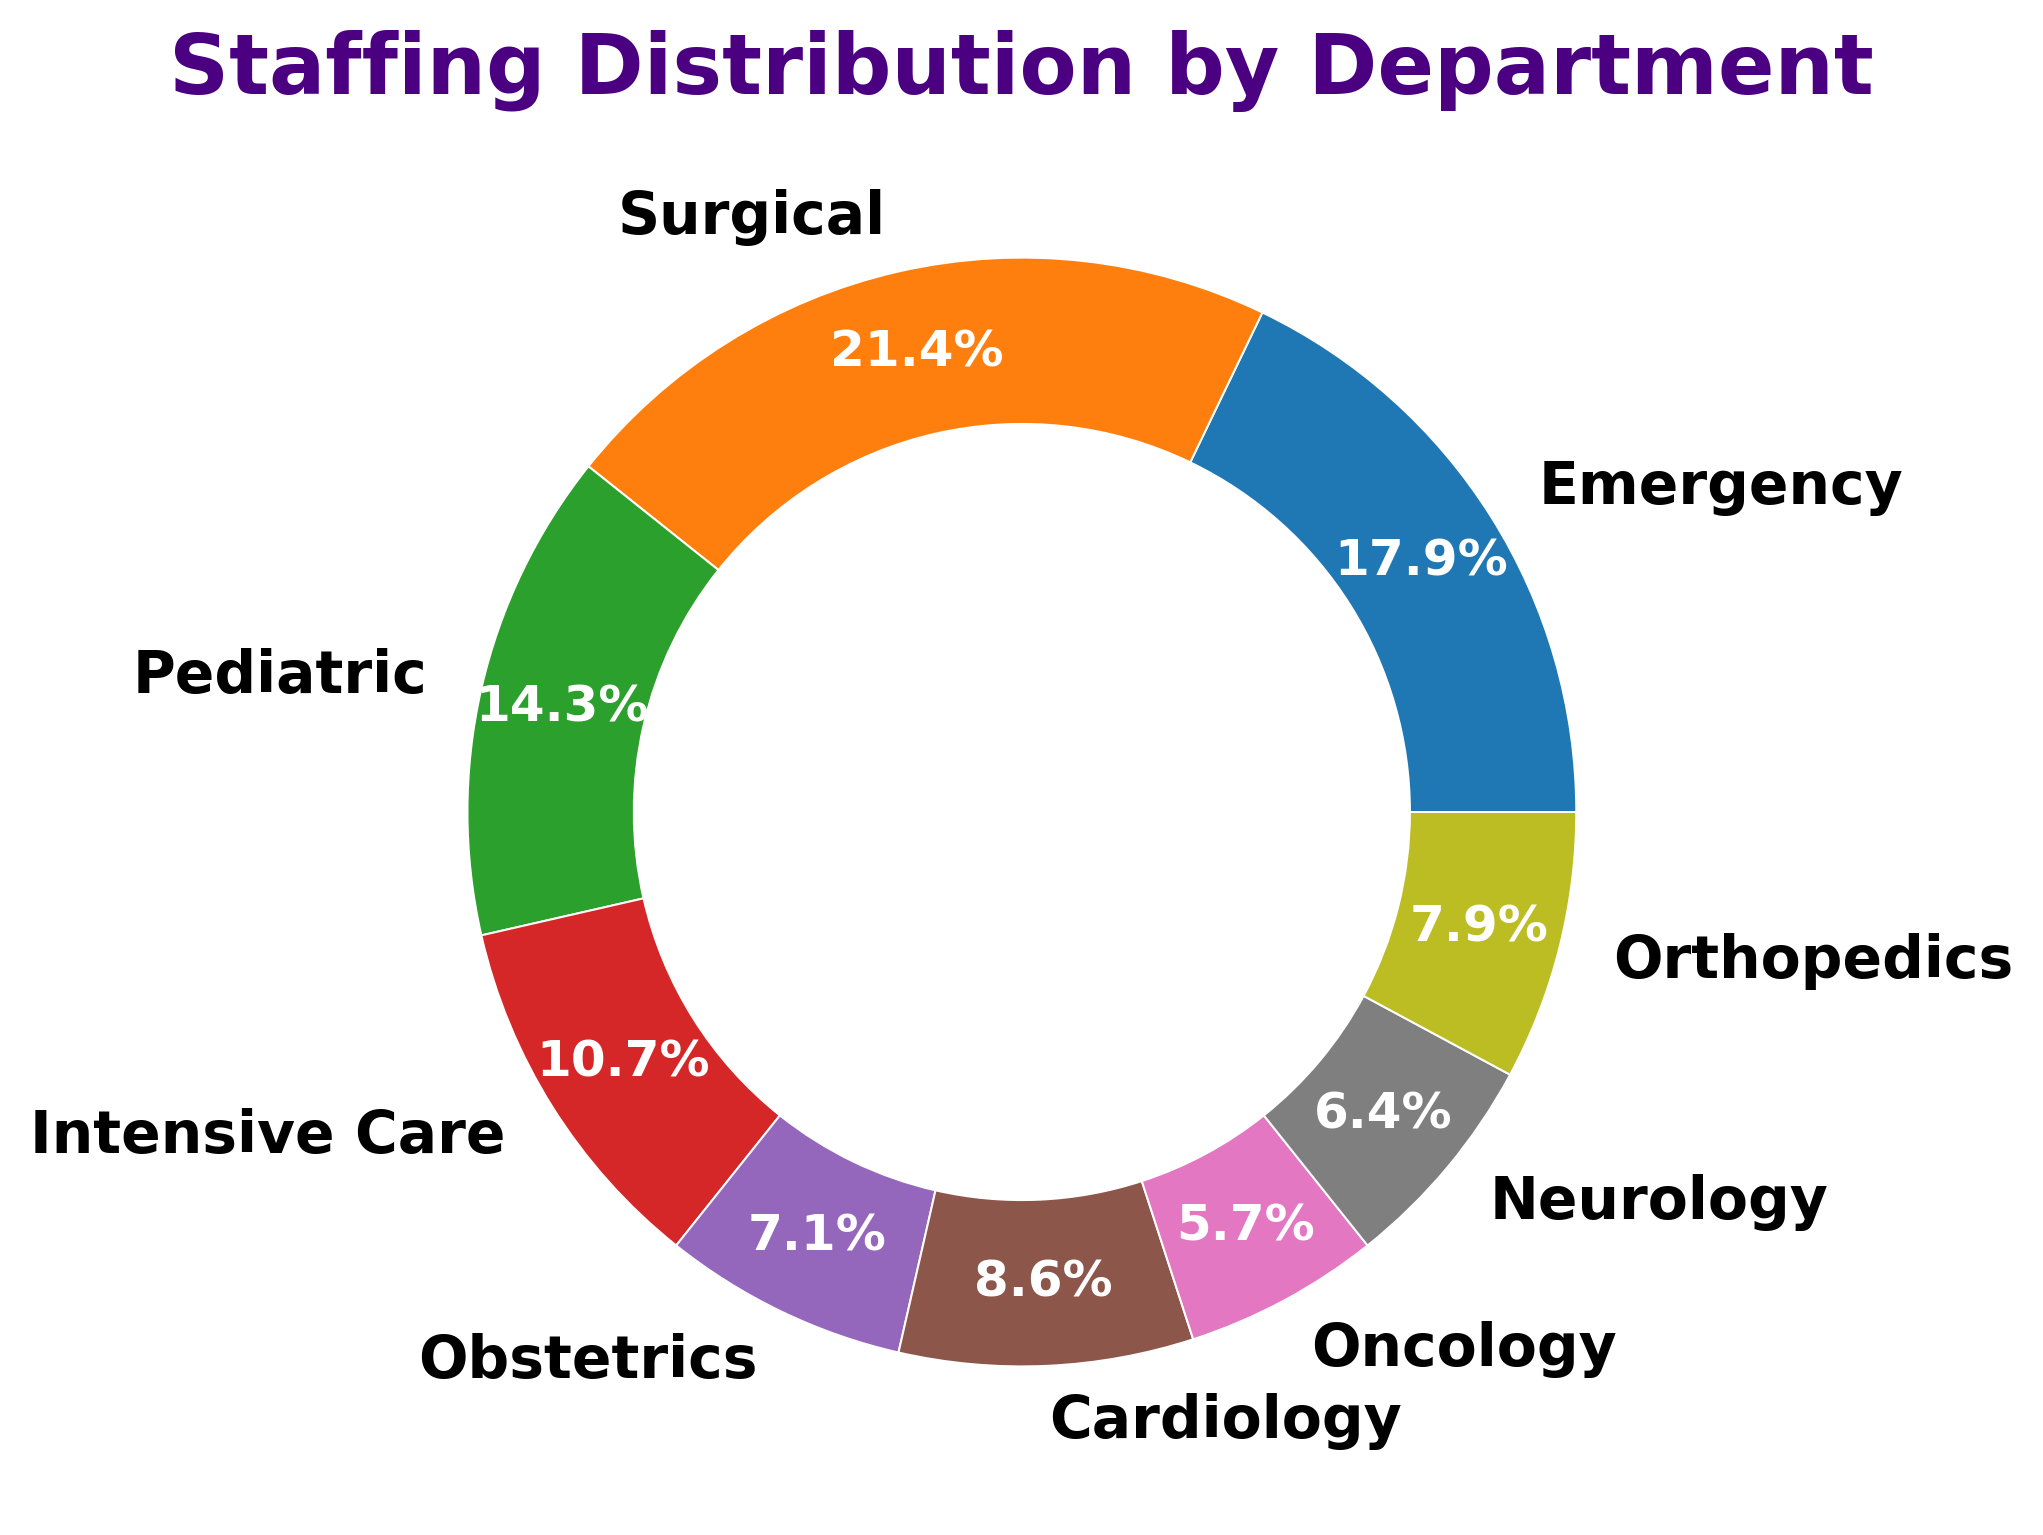What percentage of staff is allocated to the Intensive Care department? Find the slice labeled "Intensive Care" and read the percentage value displayed on the chart
Answer: 15% Which department has the fewest number of staff? Look at the smallest slice and find the corresponding department label
Answer: Oncology What is the combined staff percentage of the Emergency and Pediatric departments? Find the percentage for Emergency and Pediatric from the chart, then add them together (25% + 20%)
Answer: 45% How does the number of staff in the Surgical department compare to the Neurology department? Find the slices for Surgical and Neurology, compare the staff numbers (Surgical: 30, Neurology: 9)
Answer: Surgical has more staff What is the difference in staff count between the department with the most staff and the department with the least staff? Identify the departments with the most and least staff (Surgical: 30, Oncology: 8), then subtract the smaller number from the larger (30 - 8)
Answer: 22 What are the top three departments by staff count? Identify the three largest slices and their corresponding departments (Surgical, Emergency, Pediatric)
Answer: Surgical, Emergency, Pediatric How does staff allocation in Cardiology compare to Obstetrics? Find the slices for Cardiology and Obstetrics, compare the staff numbers (Cardiology: 12, Obstetrics: 10)
Answer: Cardiology has more staff What percentage of staff works in departments outside of Emergency, Surgical, and Pediatric? Calculate 100% minus the combined percentage for Emergency, Surgical, and Pediatric (100% - (25% + 30% + 20%))
Answer: 25% Which department has the second-largest staff allocation percentage? Identify the slice with the second-largest percentage after Surgical
Answer: Emergency If the Pediatric department were to receive 5 more staff, what would be its new percentage of the overall staff? Assume the total staff count is 140, with Pediatric initially having 20. With 5 more staff, Pediatric will have 25. The new percentage is (25/145) * 100 ≈ 17.2%
Answer: 17.2% 